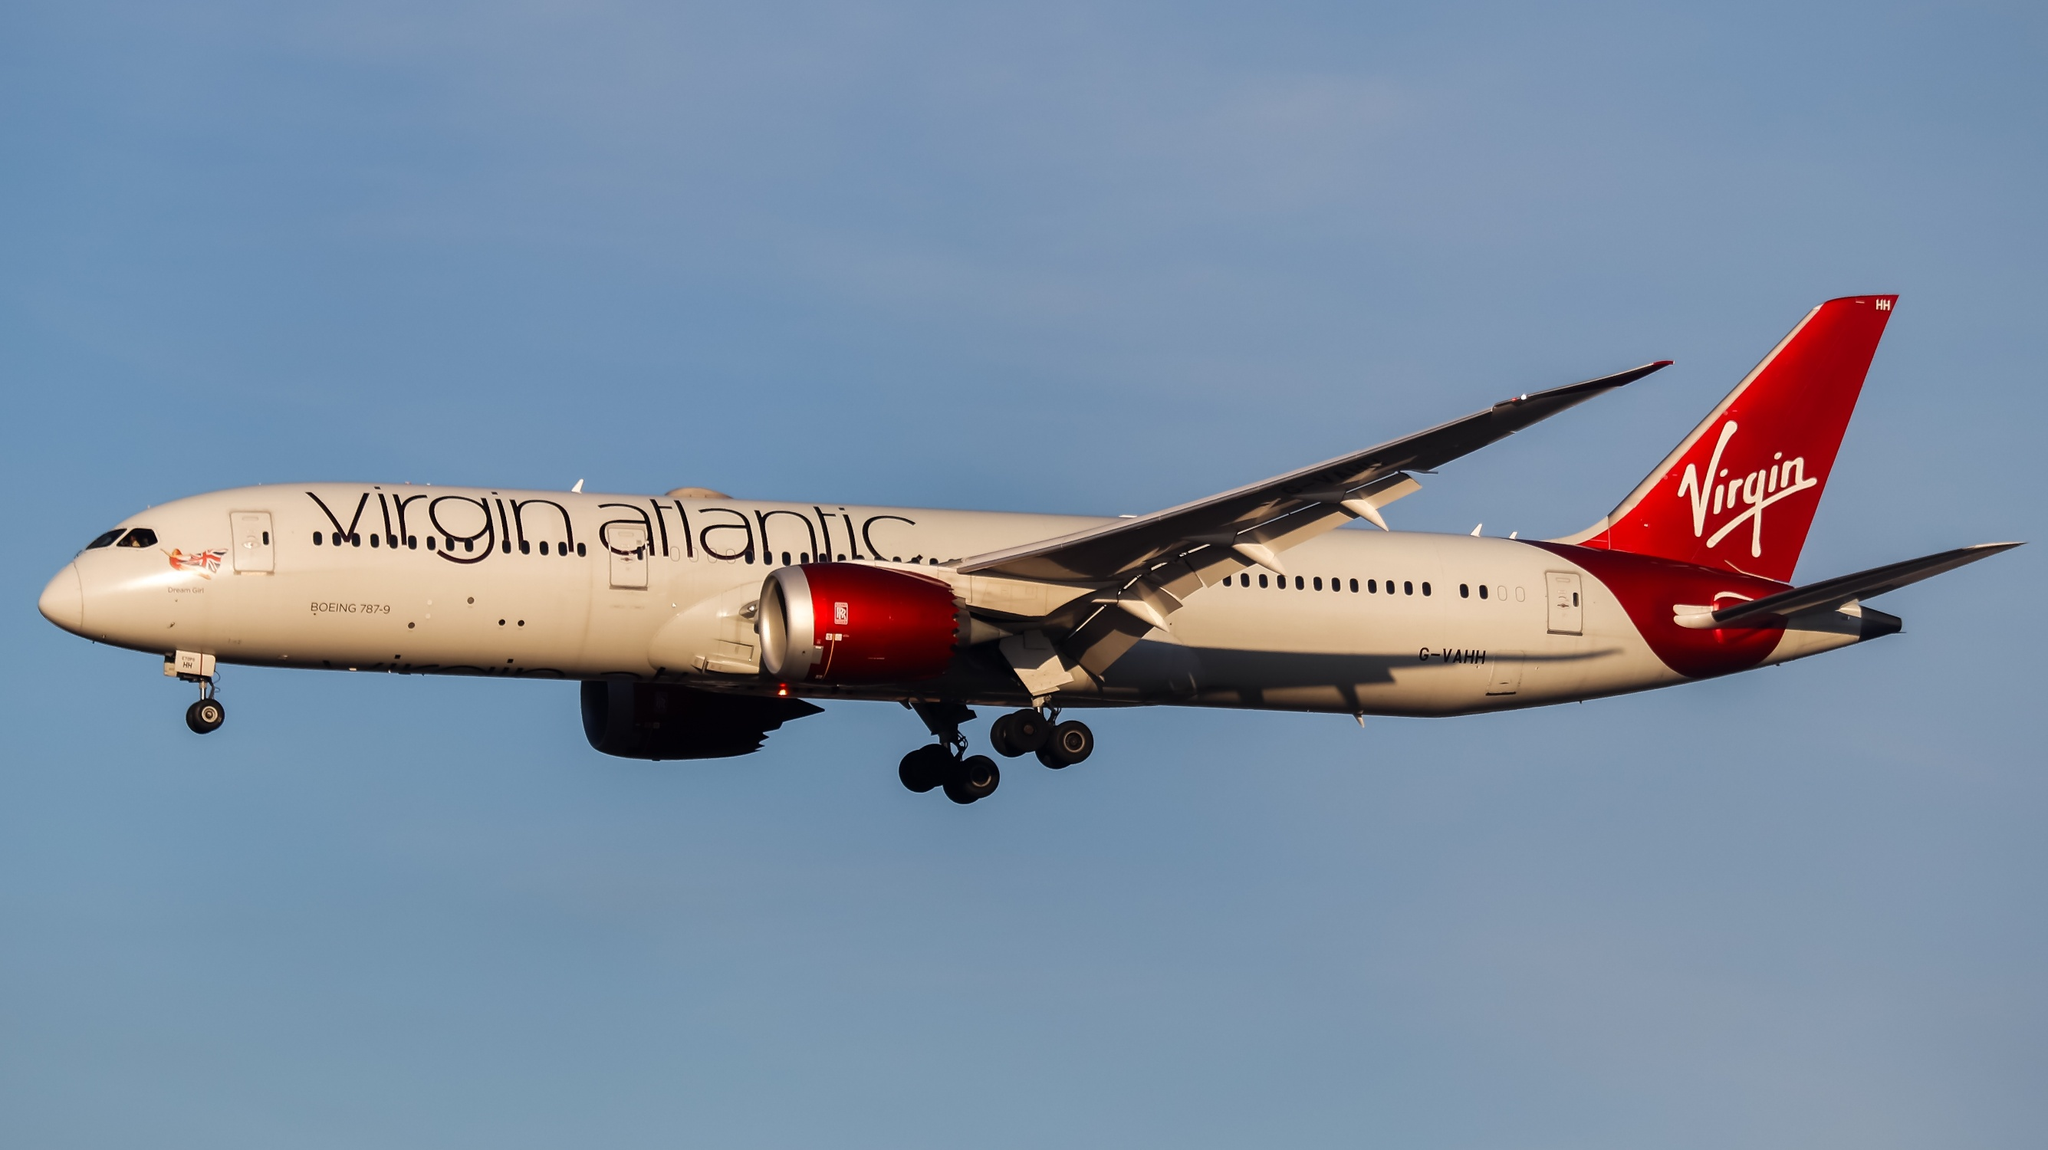What destinations has this aircraft visited, and what notable events has it experienced? This Virgin Atlantic Boeing 787-9 Dreamliner has traversed the globe, serving as an ambassador of luxury and efficiency on numerous international routes. It has graced the skies over iconic cities such as New York, London, Hong Kong, and Sydney, connecting passengers to these bustling metropolises with grace and sophistication. The aircraft has witnessed breathtaking sunrises over the Atlantic, navigated through fierce storm clouds above the Pacific, and touched down at some of the world's premier airports. Notable events in its service include transporting distinguished guests, partaking in inaugural flights of new routes, and being a part of humanitarian missions, where it delivered aid and hope to those in need. Each journey has contributed to its legacy as a pillar of modern aviation. 